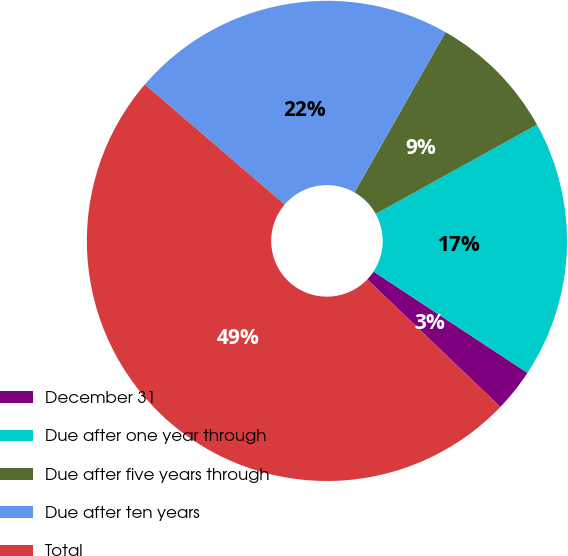Convert chart to OTSL. <chart><loc_0><loc_0><loc_500><loc_500><pie_chart><fcel>December 31<fcel>Due after one year through<fcel>Due after five years through<fcel>Due after ten years<fcel>Total<nl><fcel>2.89%<fcel>17.31%<fcel>8.73%<fcel>21.93%<fcel>49.14%<nl></chart> 